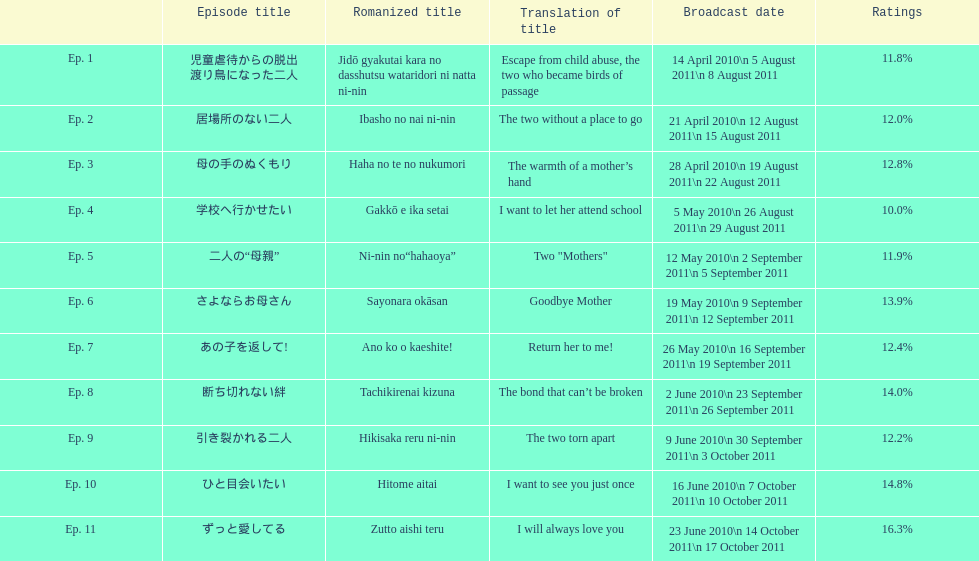Which episode had the highest ratings? Ep. 11. Which episode was named haha no te no nukumori? Ep. 3. Besides episode 10 which episode had a 14% rating? Ep. 8. 